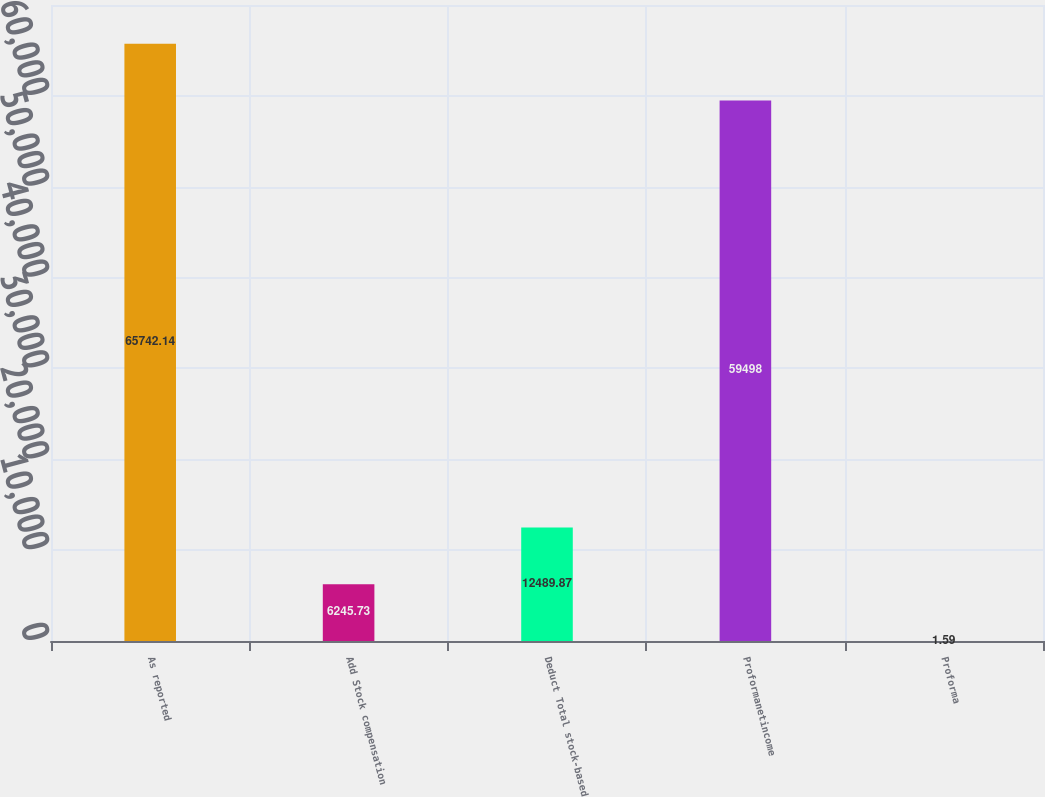Convert chart. <chart><loc_0><loc_0><loc_500><loc_500><bar_chart><fcel>As reported<fcel>Add Stock compensation<fcel>Deduct Total stock-based<fcel>Proformanetincome<fcel>Proforma<nl><fcel>65742.1<fcel>6245.73<fcel>12489.9<fcel>59498<fcel>1.59<nl></chart> 